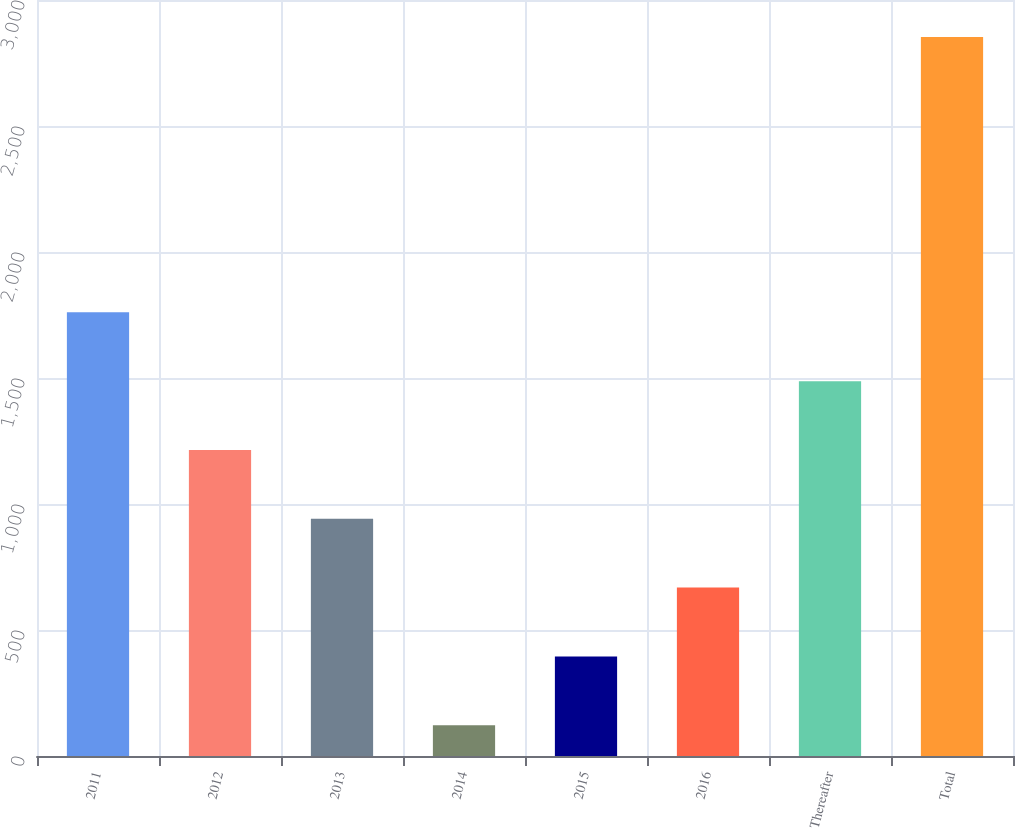<chart> <loc_0><loc_0><loc_500><loc_500><bar_chart><fcel>2011<fcel>2012<fcel>2013<fcel>2014<fcel>2015<fcel>2016<fcel>Thereafter<fcel>Total<nl><fcel>1760.6<fcel>1214.4<fcel>941.3<fcel>122<fcel>395.1<fcel>668.2<fcel>1487.5<fcel>2853<nl></chart> 